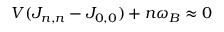Convert formula to latex. <formula><loc_0><loc_0><loc_500><loc_500>V ( J _ { n , n } - J _ { 0 , 0 } ) + n \omega _ { B } \approx 0</formula> 